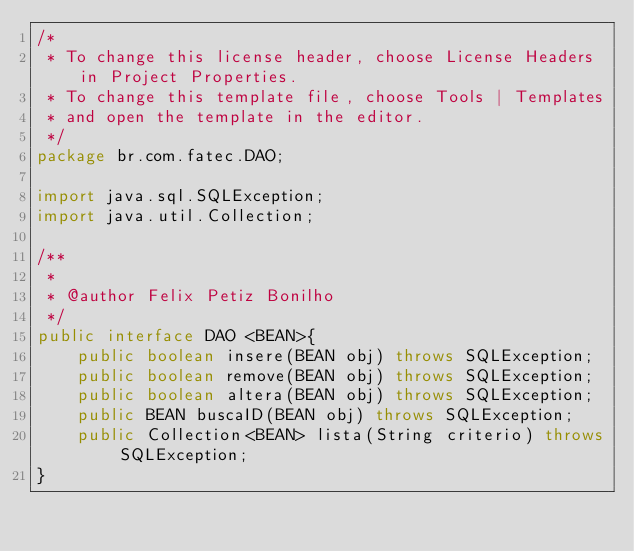Convert code to text. <code><loc_0><loc_0><loc_500><loc_500><_Java_>/*
 * To change this license header, choose License Headers in Project Properties.
 * To change this template file, choose Tools | Templates
 * and open the template in the editor.
 */
package br.com.fatec.DAO;

import java.sql.SQLException;
import java.util.Collection;

/**
 *
 * @author Felix Petiz Bonilho
 */
public interface DAO <BEAN>{
    public boolean insere(BEAN obj) throws SQLException;
    public boolean remove(BEAN obj) throws SQLException;
    public boolean altera(BEAN obj) throws SQLException;
    public BEAN buscaID(BEAN obj) throws SQLException;
    public Collection<BEAN> lista(String criterio) throws SQLException;
}
</code> 